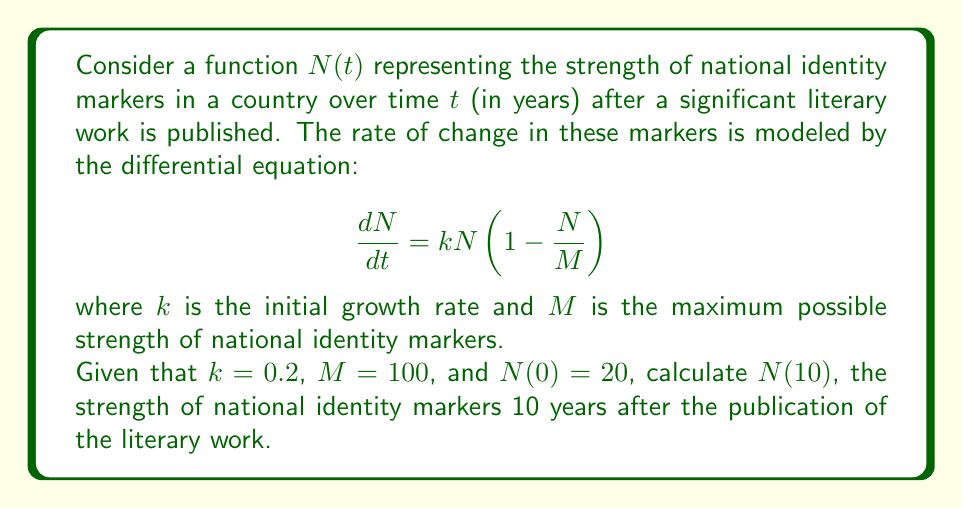Solve this math problem. To solve this problem, we need to follow these steps:

1) First, recognize that this differential equation is the logistic growth model.

2) The solution to the logistic growth equation is given by:

   $$N(t) = \frac{M}{1 + (\frac{M}{N_0} - 1)e^{-kt}}$$

   where $N_0$ is the initial value of $N$ at $t = 0$.

3) We are given:
   $k = 0.2$
   $M = 100$
   $N_0 = N(0) = 20$
   $t = 10$

4) Let's substitute these values into the equation:

   $$N(10) = \frac{100}{1 + (\frac{100}{20} - 1)e^{-0.2(10)}}$$

5) Simplify:
   $$N(10) = \frac{100}{1 + (5 - 1)e^{-2}}$$
   $$N(10) = \frac{100}{1 + 4e^{-2}}$$

6) Calculate $e^{-2}$:
   $$e^{-2} \approx 0.1353$$

7) Substitute this value:
   $$N(10) = \frac{100}{1 + 4(0.1353)} = \frac{100}{1.5412}$$

8) Perform the final division:
   $$N(10) \approx 64.8845$$

Therefore, the strength of national identity markers after 10 years is approximately 64.8845.
Answer: $N(10) \approx 64.8845$ 